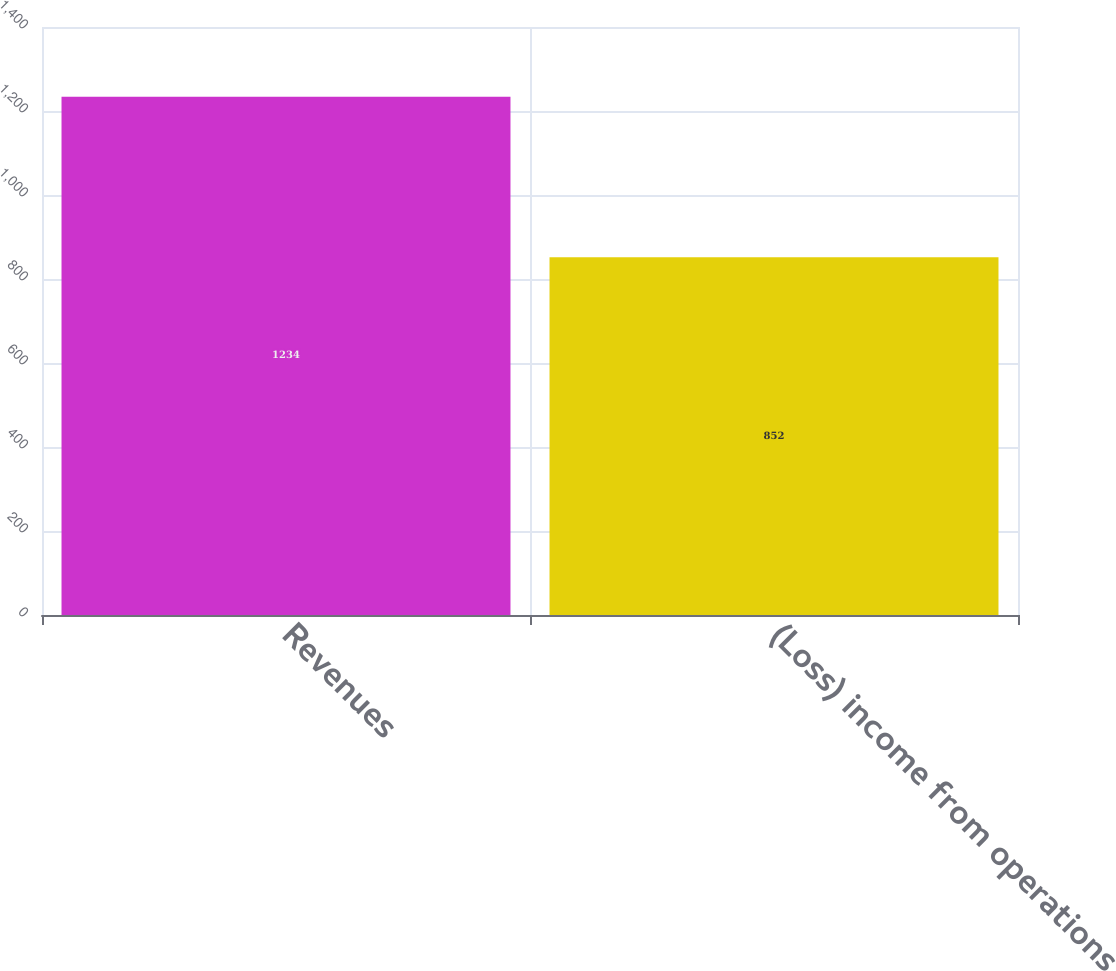Convert chart. <chart><loc_0><loc_0><loc_500><loc_500><bar_chart><fcel>Revenues<fcel>(Loss) income from operations<nl><fcel>1234<fcel>852<nl></chart> 